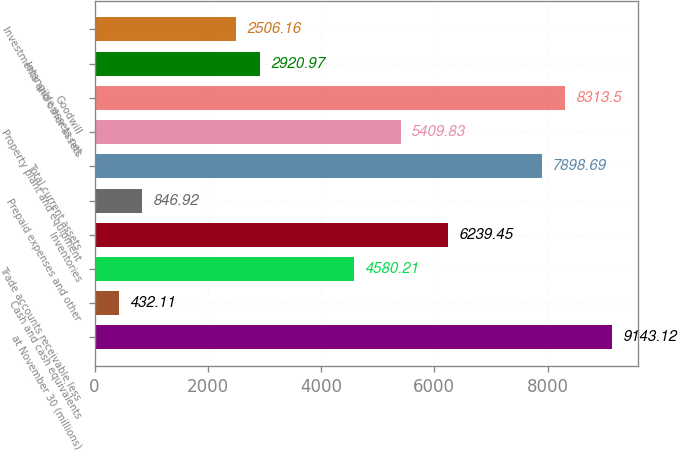Convert chart to OTSL. <chart><loc_0><loc_0><loc_500><loc_500><bar_chart><fcel>at November 30 (millions)<fcel>Cash and cash equivalents<fcel>Trade accounts receivable less<fcel>Inventories<fcel>Prepaid expenses and other<fcel>Total current assets<fcel>Property plant and equipment<fcel>Goodwill<fcel>Intangible assets net<fcel>Investments and other assets<nl><fcel>9143.12<fcel>432.11<fcel>4580.21<fcel>6239.45<fcel>846.92<fcel>7898.69<fcel>5409.83<fcel>8313.5<fcel>2920.97<fcel>2506.16<nl></chart> 